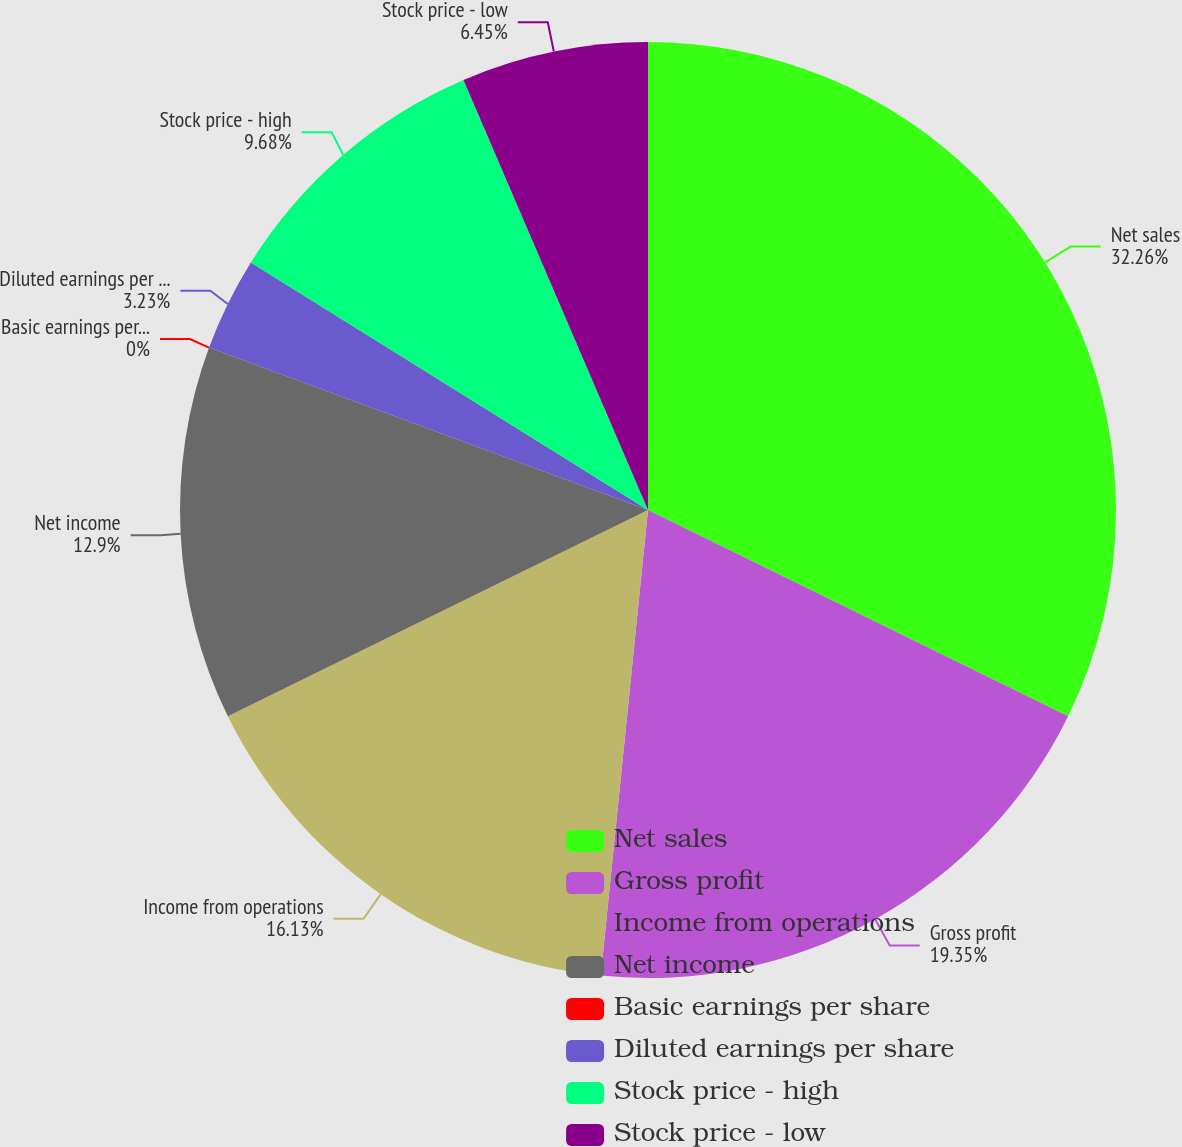<chart> <loc_0><loc_0><loc_500><loc_500><pie_chart><fcel>Net sales<fcel>Gross profit<fcel>Income from operations<fcel>Net income<fcel>Basic earnings per share<fcel>Diluted earnings per share<fcel>Stock price - high<fcel>Stock price - low<nl><fcel>32.26%<fcel>19.35%<fcel>16.13%<fcel>12.9%<fcel>0.0%<fcel>3.23%<fcel>9.68%<fcel>6.45%<nl></chart> 